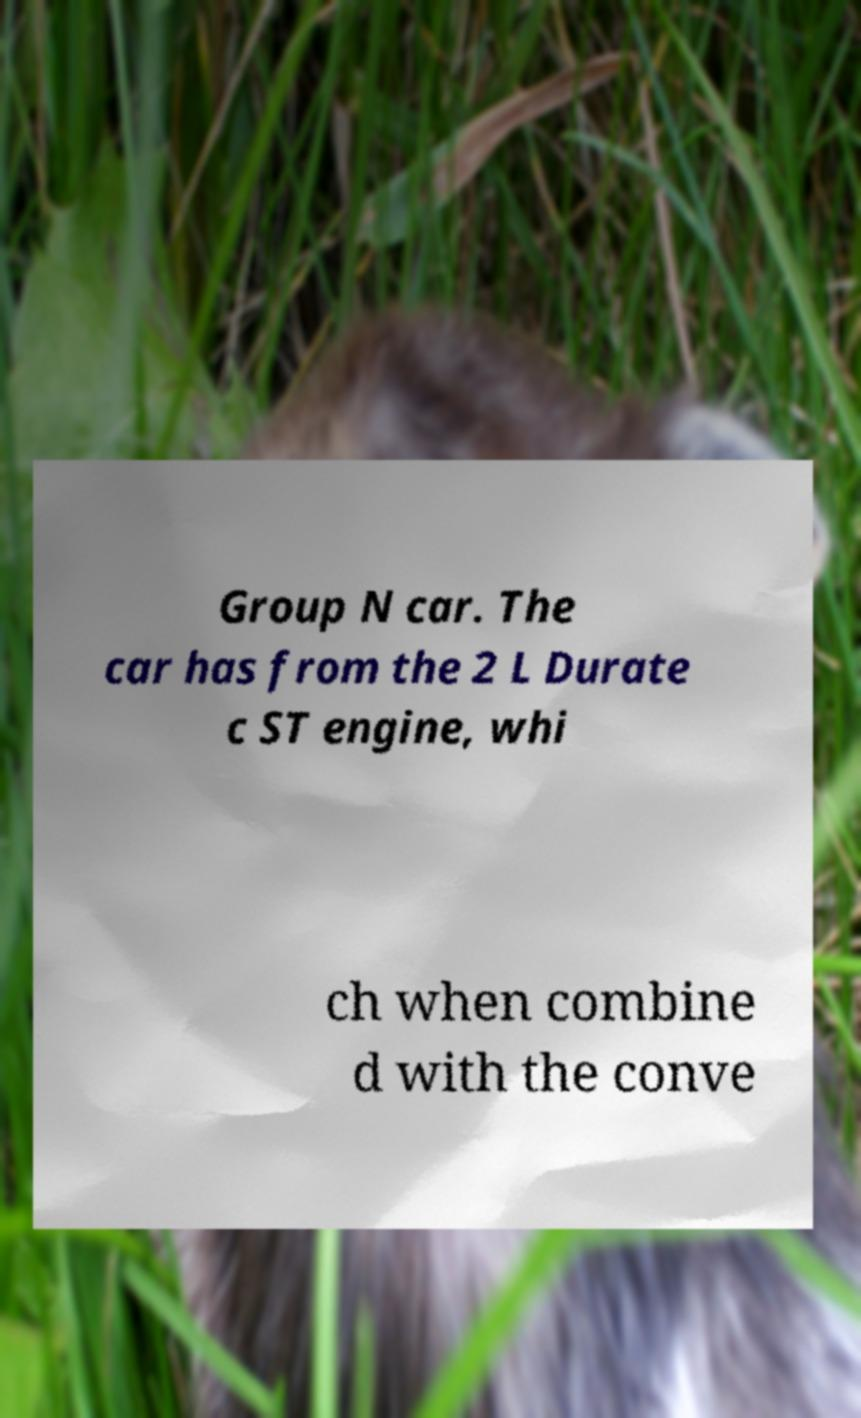Could you extract and type out the text from this image? Group N car. The car has from the 2 L Durate c ST engine, whi ch when combine d with the conve 